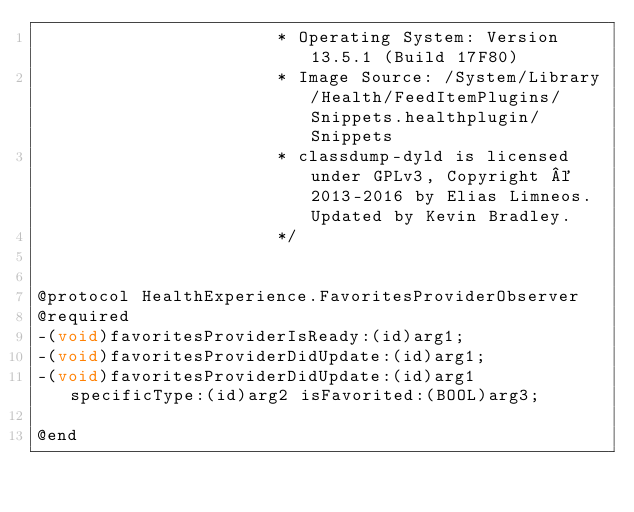<code> <loc_0><loc_0><loc_500><loc_500><_C_>                       * Operating System: Version 13.5.1 (Build 17F80)
                       * Image Source: /System/Library/Health/FeedItemPlugins/Snippets.healthplugin/Snippets
                       * classdump-dyld is licensed under GPLv3, Copyright © 2013-2016 by Elias Limneos. Updated by Kevin Bradley.
                       */


@protocol HealthExperience.FavoritesProviderObserver
@required
-(void)favoritesProviderIsReady:(id)arg1;
-(void)favoritesProviderDidUpdate:(id)arg1;
-(void)favoritesProviderDidUpdate:(id)arg1 specificType:(id)arg2 isFavorited:(BOOL)arg3;

@end

</code> 